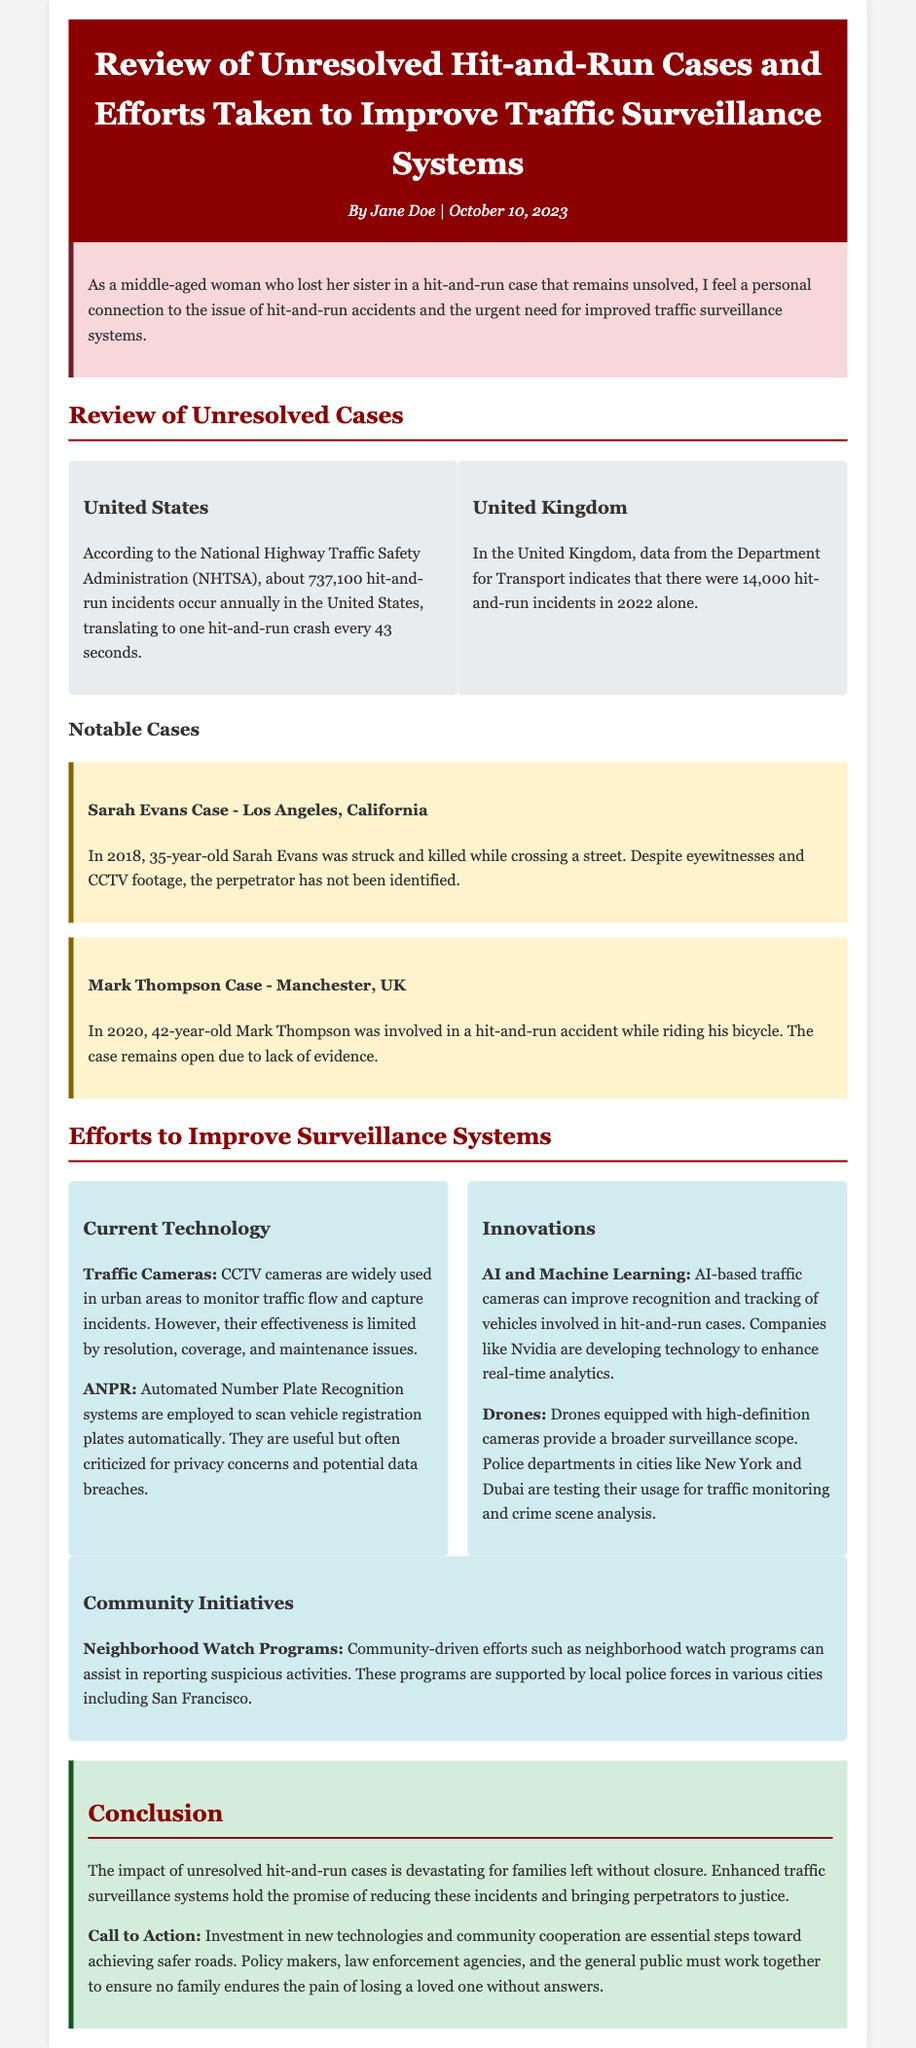What is the number of annual hit-and-run incidents in the United States? According to the National Highway Traffic Safety Administration (NHTSA), the document states that about 737,100 hit-and-run incidents occur annually in the United States.
Answer: 737,100 What year did the Sarah Evans case occur? The document mentions that the Sarah Evans case took place in 2018 when she was struck and killed while crossing a street.
Answer: 2018 What city is Mark Thompson from? The document states that the Mark Thompson case occurred in Manchester, UK, where he was involved in a hit-and-run accident.
Answer: Manchester What technology is used to scan vehicle registration plates? The document notes that Automated Number Plate Recognition systems are employed to scan vehicle registration plates automatically.
Answer: ANPR What is one community-driven initiative mentioned in the report? The report highlights that neighborhood watch programs are community-driven efforts that can assist in reporting suspicious activities.
Answer: Neighborhood Watch Programs How many hit-and-run incidents were reported in the United Kingdom in 2022? According to data from the Department for Transport, there were 14,000 hit-and-run incidents in the United Kingdom in 2022.
Answer: 14,000 What are two innovations mentioned for improving traffic surveillance? The document discusses AI and Machine Learning as well as Drones equipped with high-definition cameras as innovations for improving traffic surveillance.
Answer: AI and Drones What color is the header background in the document? The header background color is specified as #8b0000, which is a dark red shade in the document's styling.
Answer: Dark Red What is the call to action suggested in the conclusion? The document emphasizes the need for investment in new technologies and community cooperation as essential steps toward achieving safer roads.
Answer: Investment and cooperation 